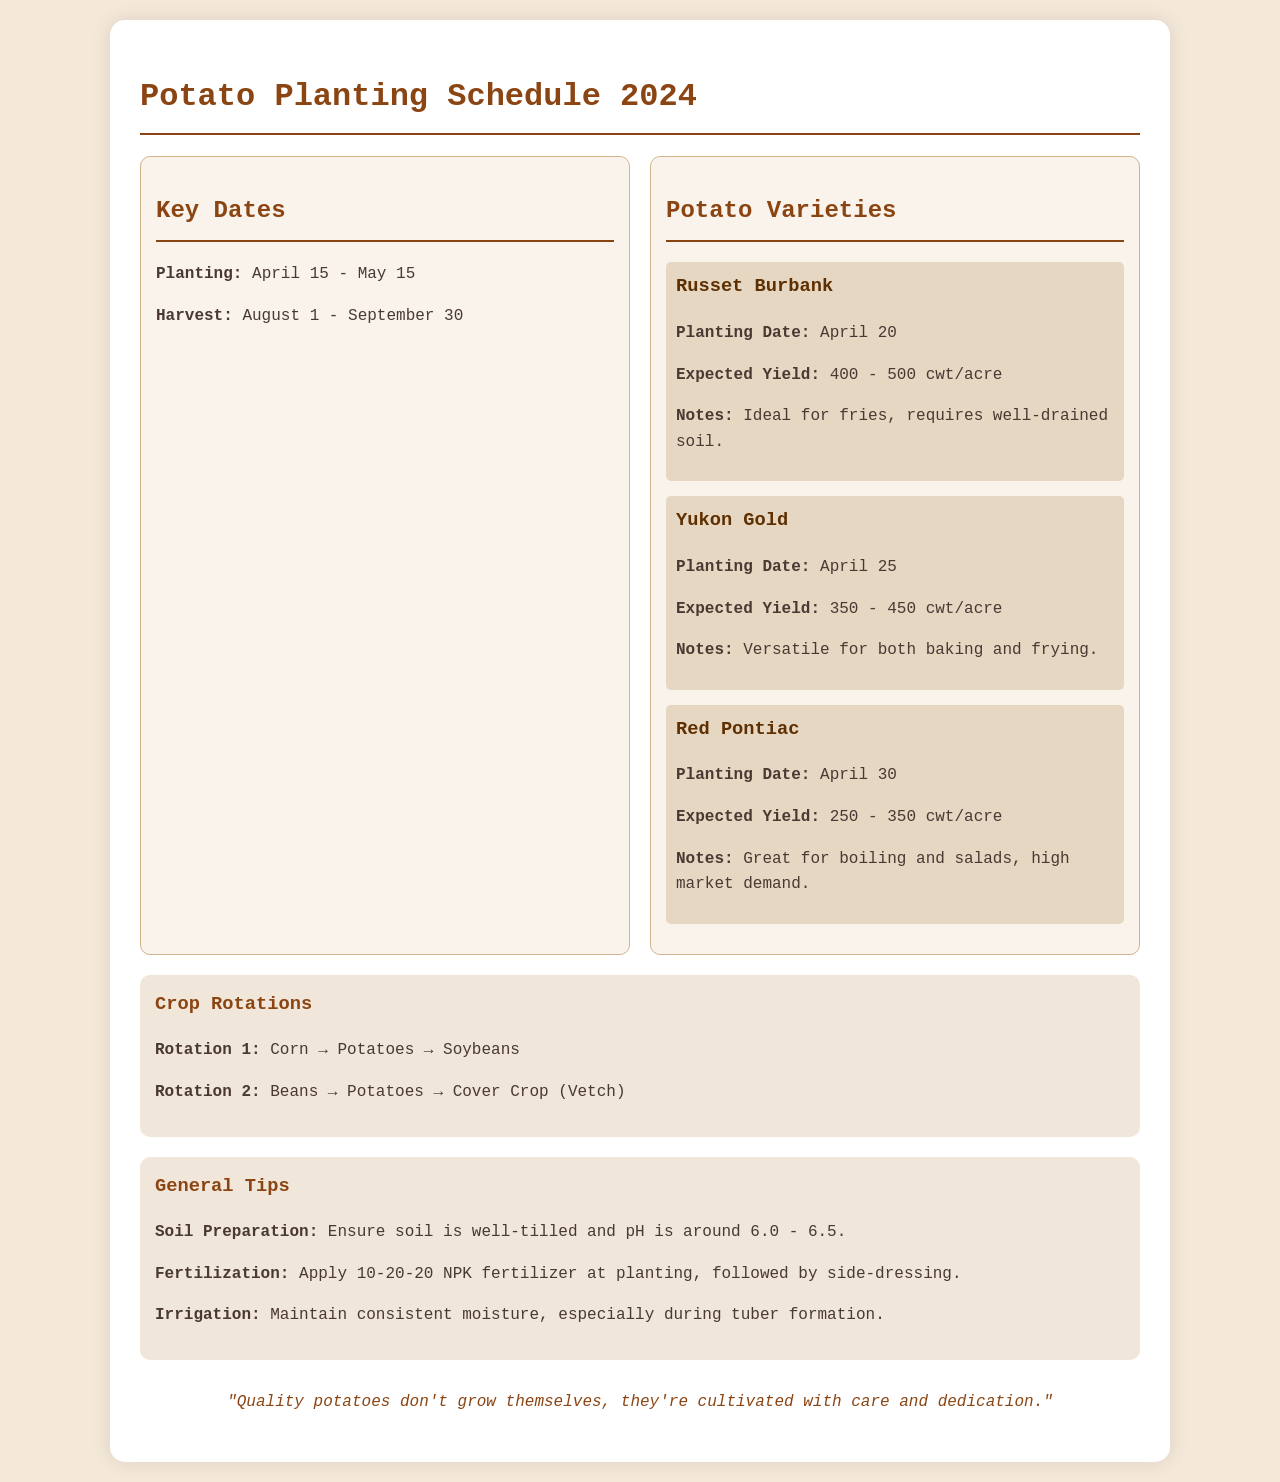What are the planting dates for potatoes? The planting dates for potatoes in the schedule range from April 15 to May 15.
Answer: April 15 - May 15 What is the expected yield for Russet Burbank potatoes? The expected yield for Russet Burbank potatoes is given as a range in the document.
Answer: 400 - 500 cwt/acre When is the harvest period for potatoes? The document specifies the harvest period for potatoes, which is from August 1 to September 30.
Answer: August 1 - September 30 What is the second crop rotation listed? The document mentions different crop rotations, including the second one specifically.
Answer: Beans → Potatoes → Cover Crop (Vetch) Which potato variety is mentioned as great for boiling and salads? The document includes a note about which potato variety holds this quality.
Answer: Red Pontiac 